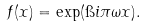Convert formula to latex. <formula><loc_0><loc_0><loc_500><loc_500>f ( x ) = \exp ( \i i \pi \omega x ) .</formula> 